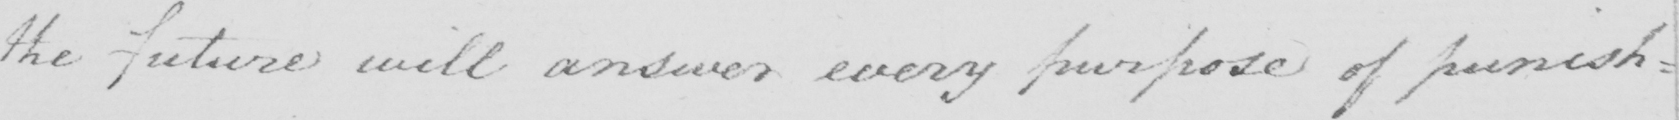What text is written in this handwritten line? the future will answer every purpose of punish= 